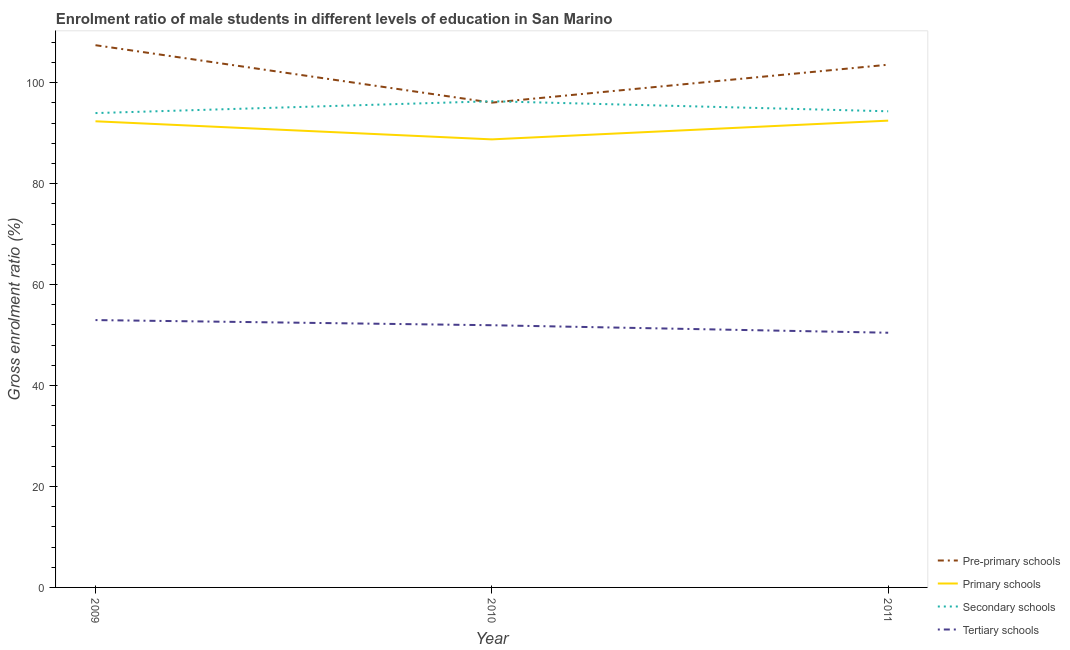Is the number of lines equal to the number of legend labels?
Make the answer very short. Yes. What is the gross enrolment ratio(female) in secondary schools in 2009?
Give a very brief answer. 93.99. Across all years, what is the maximum gross enrolment ratio(female) in primary schools?
Your answer should be compact. 92.49. Across all years, what is the minimum gross enrolment ratio(female) in primary schools?
Make the answer very short. 88.78. In which year was the gross enrolment ratio(female) in primary schools minimum?
Give a very brief answer. 2010. What is the total gross enrolment ratio(female) in primary schools in the graph?
Ensure brevity in your answer.  273.62. What is the difference between the gross enrolment ratio(female) in secondary schools in 2009 and that in 2011?
Your answer should be compact. -0.36. What is the difference between the gross enrolment ratio(female) in primary schools in 2011 and the gross enrolment ratio(female) in pre-primary schools in 2010?
Give a very brief answer. -3.57. What is the average gross enrolment ratio(female) in primary schools per year?
Provide a succinct answer. 91.21. In the year 2009, what is the difference between the gross enrolment ratio(female) in pre-primary schools and gross enrolment ratio(female) in primary schools?
Provide a short and direct response. 15.08. What is the ratio of the gross enrolment ratio(female) in pre-primary schools in 2009 to that in 2011?
Your answer should be compact. 1.04. Is the gross enrolment ratio(female) in secondary schools in 2010 less than that in 2011?
Give a very brief answer. No. What is the difference between the highest and the second highest gross enrolment ratio(female) in primary schools?
Your answer should be very brief. 0.13. What is the difference between the highest and the lowest gross enrolment ratio(female) in pre-primary schools?
Ensure brevity in your answer.  11.38. Is it the case that in every year, the sum of the gross enrolment ratio(female) in primary schools and gross enrolment ratio(female) in tertiary schools is greater than the sum of gross enrolment ratio(female) in pre-primary schools and gross enrolment ratio(female) in secondary schools?
Your answer should be very brief. No. Is it the case that in every year, the sum of the gross enrolment ratio(female) in pre-primary schools and gross enrolment ratio(female) in primary schools is greater than the gross enrolment ratio(female) in secondary schools?
Keep it short and to the point. Yes. Is the gross enrolment ratio(female) in tertiary schools strictly greater than the gross enrolment ratio(female) in primary schools over the years?
Provide a short and direct response. No. How many lines are there?
Offer a very short reply. 4. Are the values on the major ticks of Y-axis written in scientific E-notation?
Keep it short and to the point. No. Does the graph contain grids?
Offer a very short reply. No. Where does the legend appear in the graph?
Provide a short and direct response. Bottom right. How are the legend labels stacked?
Provide a short and direct response. Vertical. What is the title of the graph?
Provide a short and direct response. Enrolment ratio of male students in different levels of education in San Marino. Does "Others" appear as one of the legend labels in the graph?
Provide a succinct answer. No. What is the label or title of the X-axis?
Your answer should be very brief. Year. What is the Gross enrolment ratio (%) of Pre-primary schools in 2009?
Provide a short and direct response. 107.43. What is the Gross enrolment ratio (%) in Primary schools in 2009?
Your response must be concise. 92.36. What is the Gross enrolment ratio (%) in Secondary schools in 2009?
Make the answer very short. 93.99. What is the Gross enrolment ratio (%) in Tertiary schools in 2009?
Ensure brevity in your answer.  52.97. What is the Gross enrolment ratio (%) in Pre-primary schools in 2010?
Provide a succinct answer. 96.05. What is the Gross enrolment ratio (%) of Primary schools in 2010?
Provide a succinct answer. 88.78. What is the Gross enrolment ratio (%) in Secondary schools in 2010?
Make the answer very short. 96.33. What is the Gross enrolment ratio (%) of Tertiary schools in 2010?
Your answer should be compact. 51.95. What is the Gross enrolment ratio (%) in Pre-primary schools in 2011?
Provide a short and direct response. 103.57. What is the Gross enrolment ratio (%) of Primary schools in 2011?
Your response must be concise. 92.49. What is the Gross enrolment ratio (%) of Secondary schools in 2011?
Give a very brief answer. 94.34. What is the Gross enrolment ratio (%) in Tertiary schools in 2011?
Ensure brevity in your answer.  50.46. Across all years, what is the maximum Gross enrolment ratio (%) of Pre-primary schools?
Give a very brief answer. 107.43. Across all years, what is the maximum Gross enrolment ratio (%) in Primary schools?
Keep it short and to the point. 92.49. Across all years, what is the maximum Gross enrolment ratio (%) of Secondary schools?
Give a very brief answer. 96.33. Across all years, what is the maximum Gross enrolment ratio (%) in Tertiary schools?
Your answer should be compact. 52.97. Across all years, what is the minimum Gross enrolment ratio (%) in Pre-primary schools?
Provide a short and direct response. 96.05. Across all years, what is the minimum Gross enrolment ratio (%) of Primary schools?
Offer a terse response. 88.78. Across all years, what is the minimum Gross enrolment ratio (%) in Secondary schools?
Provide a short and direct response. 93.99. Across all years, what is the minimum Gross enrolment ratio (%) in Tertiary schools?
Ensure brevity in your answer.  50.46. What is the total Gross enrolment ratio (%) in Pre-primary schools in the graph?
Offer a very short reply. 307.06. What is the total Gross enrolment ratio (%) in Primary schools in the graph?
Offer a terse response. 273.62. What is the total Gross enrolment ratio (%) of Secondary schools in the graph?
Your answer should be compact. 284.66. What is the total Gross enrolment ratio (%) in Tertiary schools in the graph?
Make the answer very short. 155.39. What is the difference between the Gross enrolment ratio (%) in Pre-primary schools in 2009 and that in 2010?
Give a very brief answer. 11.38. What is the difference between the Gross enrolment ratio (%) of Primary schools in 2009 and that in 2010?
Make the answer very short. 3.58. What is the difference between the Gross enrolment ratio (%) of Secondary schools in 2009 and that in 2010?
Provide a succinct answer. -2.35. What is the difference between the Gross enrolment ratio (%) of Tertiary schools in 2009 and that in 2010?
Ensure brevity in your answer.  1.02. What is the difference between the Gross enrolment ratio (%) of Pre-primary schools in 2009 and that in 2011?
Your answer should be compact. 3.86. What is the difference between the Gross enrolment ratio (%) of Primary schools in 2009 and that in 2011?
Provide a succinct answer. -0.13. What is the difference between the Gross enrolment ratio (%) of Secondary schools in 2009 and that in 2011?
Provide a succinct answer. -0.36. What is the difference between the Gross enrolment ratio (%) of Tertiary schools in 2009 and that in 2011?
Offer a very short reply. 2.51. What is the difference between the Gross enrolment ratio (%) in Pre-primary schools in 2010 and that in 2011?
Your answer should be very brief. -7.52. What is the difference between the Gross enrolment ratio (%) of Primary schools in 2010 and that in 2011?
Offer a terse response. -3.71. What is the difference between the Gross enrolment ratio (%) of Secondary schools in 2010 and that in 2011?
Ensure brevity in your answer.  1.99. What is the difference between the Gross enrolment ratio (%) of Tertiary schools in 2010 and that in 2011?
Make the answer very short. 1.49. What is the difference between the Gross enrolment ratio (%) in Pre-primary schools in 2009 and the Gross enrolment ratio (%) in Primary schools in 2010?
Ensure brevity in your answer.  18.66. What is the difference between the Gross enrolment ratio (%) of Pre-primary schools in 2009 and the Gross enrolment ratio (%) of Secondary schools in 2010?
Your answer should be compact. 11.1. What is the difference between the Gross enrolment ratio (%) in Pre-primary schools in 2009 and the Gross enrolment ratio (%) in Tertiary schools in 2010?
Provide a short and direct response. 55.48. What is the difference between the Gross enrolment ratio (%) of Primary schools in 2009 and the Gross enrolment ratio (%) of Secondary schools in 2010?
Your answer should be very brief. -3.97. What is the difference between the Gross enrolment ratio (%) in Primary schools in 2009 and the Gross enrolment ratio (%) in Tertiary schools in 2010?
Your response must be concise. 40.41. What is the difference between the Gross enrolment ratio (%) in Secondary schools in 2009 and the Gross enrolment ratio (%) in Tertiary schools in 2010?
Your response must be concise. 42.03. What is the difference between the Gross enrolment ratio (%) in Pre-primary schools in 2009 and the Gross enrolment ratio (%) in Primary schools in 2011?
Make the answer very short. 14.95. What is the difference between the Gross enrolment ratio (%) in Pre-primary schools in 2009 and the Gross enrolment ratio (%) in Secondary schools in 2011?
Make the answer very short. 13.09. What is the difference between the Gross enrolment ratio (%) in Pre-primary schools in 2009 and the Gross enrolment ratio (%) in Tertiary schools in 2011?
Your answer should be very brief. 56.97. What is the difference between the Gross enrolment ratio (%) in Primary schools in 2009 and the Gross enrolment ratio (%) in Secondary schools in 2011?
Your answer should be compact. -1.98. What is the difference between the Gross enrolment ratio (%) of Primary schools in 2009 and the Gross enrolment ratio (%) of Tertiary schools in 2011?
Offer a terse response. 41.89. What is the difference between the Gross enrolment ratio (%) of Secondary schools in 2009 and the Gross enrolment ratio (%) of Tertiary schools in 2011?
Your response must be concise. 43.52. What is the difference between the Gross enrolment ratio (%) in Pre-primary schools in 2010 and the Gross enrolment ratio (%) in Primary schools in 2011?
Make the answer very short. 3.57. What is the difference between the Gross enrolment ratio (%) in Pre-primary schools in 2010 and the Gross enrolment ratio (%) in Secondary schools in 2011?
Offer a terse response. 1.71. What is the difference between the Gross enrolment ratio (%) of Pre-primary schools in 2010 and the Gross enrolment ratio (%) of Tertiary schools in 2011?
Offer a very short reply. 45.59. What is the difference between the Gross enrolment ratio (%) of Primary schools in 2010 and the Gross enrolment ratio (%) of Secondary schools in 2011?
Ensure brevity in your answer.  -5.57. What is the difference between the Gross enrolment ratio (%) in Primary schools in 2010 and the Gross enrolment ratio (%) in Tertiary schools in 2011?
Your answer should be compact. 38.31. What is the difference between the Gross enrolment ratio (%) of Secondary schools in 2010 and the Gross enrolment ratio (%) of Tertiary schools in 2011?
Your response must be concise. 45.87. What is the average Gross enrolment ratio (%) in Pre-primary schools per year?
Your answer should be very brief. 102.35. What is the average Gross enrolment ratio (%) in Primary schools per year?
Offer a terse response. 91.21. What is the average Gross enrolment ratio (%) of Secondary schools per year?
Give a very brief answer. 94.89. What is the average Gross enrolment ratio (%) of Tertiary schools per year?
Provide a short and direct response. 51.8. In the year 2009, what is the difference between the Gross enrolment ratio (%) of Pre-primary schools and Gross enrolment ratio (%) of Primary schools?
Make the answer very short. 15.08. In the year 2009, what is the difference between the Gross enrolment ratio (%) of Pre-primary schools and Gross enrolment ratio (%) of Secondary schools?
Provide a short and direct response. 13.45. In the year 2009, what is the difference between the Gross enrolment ratio (%) of Pre-primary schools and Gross enrolment ratio (%) of Tertiary schools?
Your response must be concise. 54.46. In the year 2009, what is the difference between the Gross enrolment ratio (%) of Primary schools and Gross enrolment ratio (%) of Secondary schools?
Give a very brief answer. -1.63. In the year 2009, what is the difference between the Gross enrolment ratio (%) of Primary schools and Gross enrolment ratio (%) of Tertiary schools?
Offer a terse response. 39.39. In the year 2009, what is the difference between the Gross enrolment ratio (%) of Secondary schools and Gross enrolment ratio (%) of Tertiary schools?
Keep it short and to the point. 41.01. In the year 2010, what is the difference between the Gross enrolment ratio (%) of Pre-primary schools and Gross enrolment ratio (%) of Primary schools?
Give a very brief answer. 7.28. In the year 2010, what is the difference between the Gross enrolment ratio (%) in Pre-primary schools and Gross enrolment ratio (%) in Secondary schools?
Provide a short and direct response. -0.28. In the year 2010, what is the difference between the Gross enrolment ratio (%) in Pre-primary schools and Gross enrolment ratio (%) in Tertiary schools?
Offer a very short reply. 44.1. In the year 2010, what is the difference between the Gross enrolment ratio (%) in Primary schools and Gross enrolment ratio (%) in Secondary schools?
Ensure brevity in your answer.  -7.56. In the year 2010, what is the difference between the Gross enrolment ratio (%) of Primary schools and Gross enrolment ratio (%) of Tertiary schools?
Keep it short and to the point. 36.82. In the year 2010, what is the difference between the Gross enrolment ratio (%) of Secondary schools and Gross enrolment ratio (%) of Tertiary schools?
Make the answer very short. 44.38. In the year 2011, what is the difference between the Gross enrolment ratio (%) in Pre-primary schools and Gross enrolment ratio (%) in Primary schools?
Offer a terse response. 11.08. In the year 2011, what is the difference between the Gross enrolment ratio (%) in Pre-primary schools and Gross enrolment ratio (%) in Secondary schools?
Ensure brevity in your answer.  9.23. In the year 2011, what is the difference between the Gross enrolment ratio (%) in Pre-primary schools and Gross enrolment ratio (%) in Tertiary schools?
Keep it short and to the point. 53.11. In the year 2011, what is the difference between the Gross enrolment ratio (%) in Primary schools and Gross enrolment ratio (%) in Secondary schools?
Your answer should be compact. -1.85. In the year 2011, what is the difference between the Gross enrolment ratio (%) in Primary schools and Gross enrolment ratio (%) in Tertiary schools?
Your answer should be compact. 42.02. In the year 2011, what is the difference between the Gross enrolment ratio (%) in Secondary schools and Gross enrolment ratio (%) in Tertiary schools?
Your response must be concise. 43.88. What is the ratio of the Gross enrolment ratio (%) of Pre-primary schools in 2009 to that in 2010?
Give a very brief answer. 1.12. What is the ratio of the Gross enrolment ratio (%) in Primary schools in 2009 to that in 2010?
Ensure brevity in your answer.  1.04. What is the ratio of the Gross enrolment ratio (%) in Secondary schools in 2009 to that in 2010?
Provide a succinct answer. 0.98. What is the ratio of the Gross enrolment ratio (%) in Tertiary schools in 2009 to that in 2010?
Your answer should be very brief. 1.02. What is the ratio of the Gross enrolment ratio (%) in Pre-primary schools in 2009 to that in 2011?
Provide a short and direct response. 1.04. What is the ratio of the Gross enrolment ratio (%) of Tertiary schools in 2009 to that in 2011?
Make the answer very short. 1.05. What is the ratio of the Gross enrolment ratio (%) in Pre-primary schools in 2010 to that in 2011?
Your response must be concise. 0.93. What is the ratio of the Gross enrolment ratio (%) in Primary schools in 2010 to that in 2011?
Your answer should be compact. 0.96. What is the ratio of the Gross enrolment ratio (%) in Secondary schools in 2010 to that in 2011?
Ensure brevity in your answer.  1.02. What is the ratio of the Gross enrolment ratio (%) of Tertiary schools in 2010 to that in 2011?
Make the answer very short. 1.03. What is the difference between the highest and the second highest Gross enrolment ratio (%) of Pre-primary schools?
Keep it short and to the point. 3.86. What is the difference between the highest and the second highest Gross enrolment ratio (%) of Primary schools?
Make the answer very short. 0.13. What is the difference between the highest and the second highest Gross enrolment ratio (%) of Secondary schools?
Your answer should be compact. 1.99. What is the difference between the highest and the second highest Gross enrolment ratio (%) of Tertiary schools?
Keep it short and to the point. 1.02. What is the difference between the highest and the lowest Gross enrolment ratio (%) of Pre-primary schools?
Your response must be concise. 11.38. What is the difference between the highest and the lowest Gross enrolment ratio (%) in Primary schools?
Your answer should be very brief. 3.71. What is the difference between the highest and the lowest Gross enrolment ratio (%) of Secondary schools?
Provide a short and direct response. 2.35. What is the difference between the highest and the lowest Gross enrolment ratio (%) in Tertiary schools?
Your answer should be compact. 2.51. 